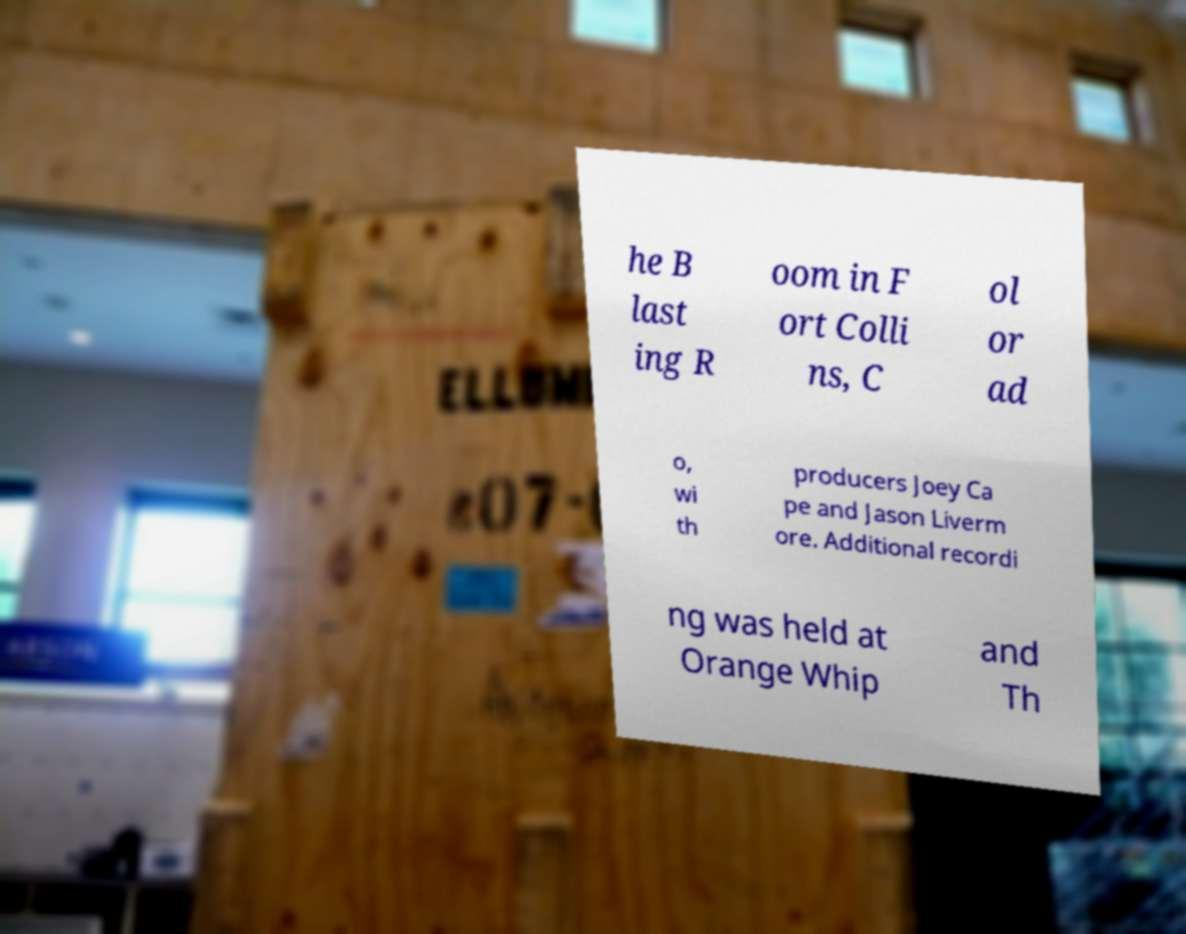What messages or text are displayed in this image? I need them in a readable, typed format. he B last ing R oom in F ort Colli ns, C ol or ad o, wi th producers Joey Ca pe and Jason Liverm ore. Additional recordi ng was held at Orange Whip and Th 